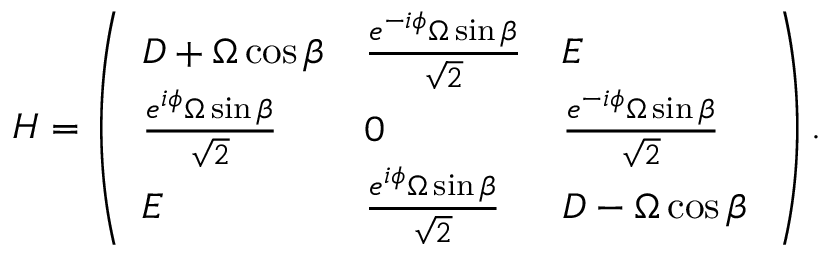<formula> <loc_0><loc_0><loc_500><loc_500>H = \left ( \begin{array} { l l l } { D + \Omega \cos \beta } & { \frac { e ^ { - i \phi } \Omega \sin \beta } { { \sqrt { 2 } } } } & { E } \\ { \frac { e ^ { i \phi } \Omega \sin \beta } { \sqrt { 2 } } } & { 0 } & { \frac { e ^ { - i \phi } \Omega \sin \beta } { { \sqrt { 2 } } } } \\ { E } & { \frac { e ^ { i \phi } \Omega \sin \beta } { \sqrt { 2 } } } & { D - \Omega \cos \beta \, } \end{array} \right ) .</formula> 